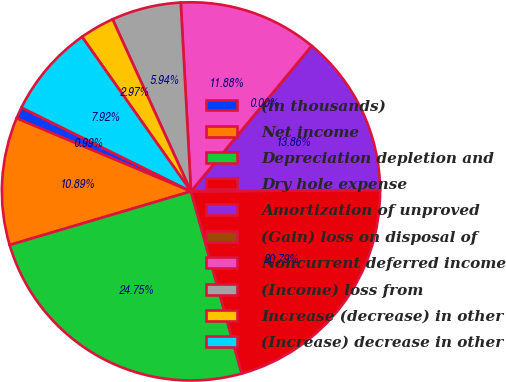Convert chart. <chart><loc_0><loc_0><loc_500><loc_500><pie_chart><fcel>(in thousands)<fcel>Net income<fcel>Depreciation depletion and<fcel>Dry hole expense<fcel>Amortization of unproved<fcel>(Gain) loss on disposal of<fcel>Noncurrent deferred income<fcel>(Income) loss from<fcel>Increase (decrease) in other<fcel>(Increase) decrease in other<nl><fcel>0.99%<fcel>10.89%<fcel>24.75%<fcel>20.79%<fcel>13.86%<fcel>0.0%<fcel>11.88%<fcel>5.94%<fcel>2.97%<fcel>7.92%<nl></chart> 